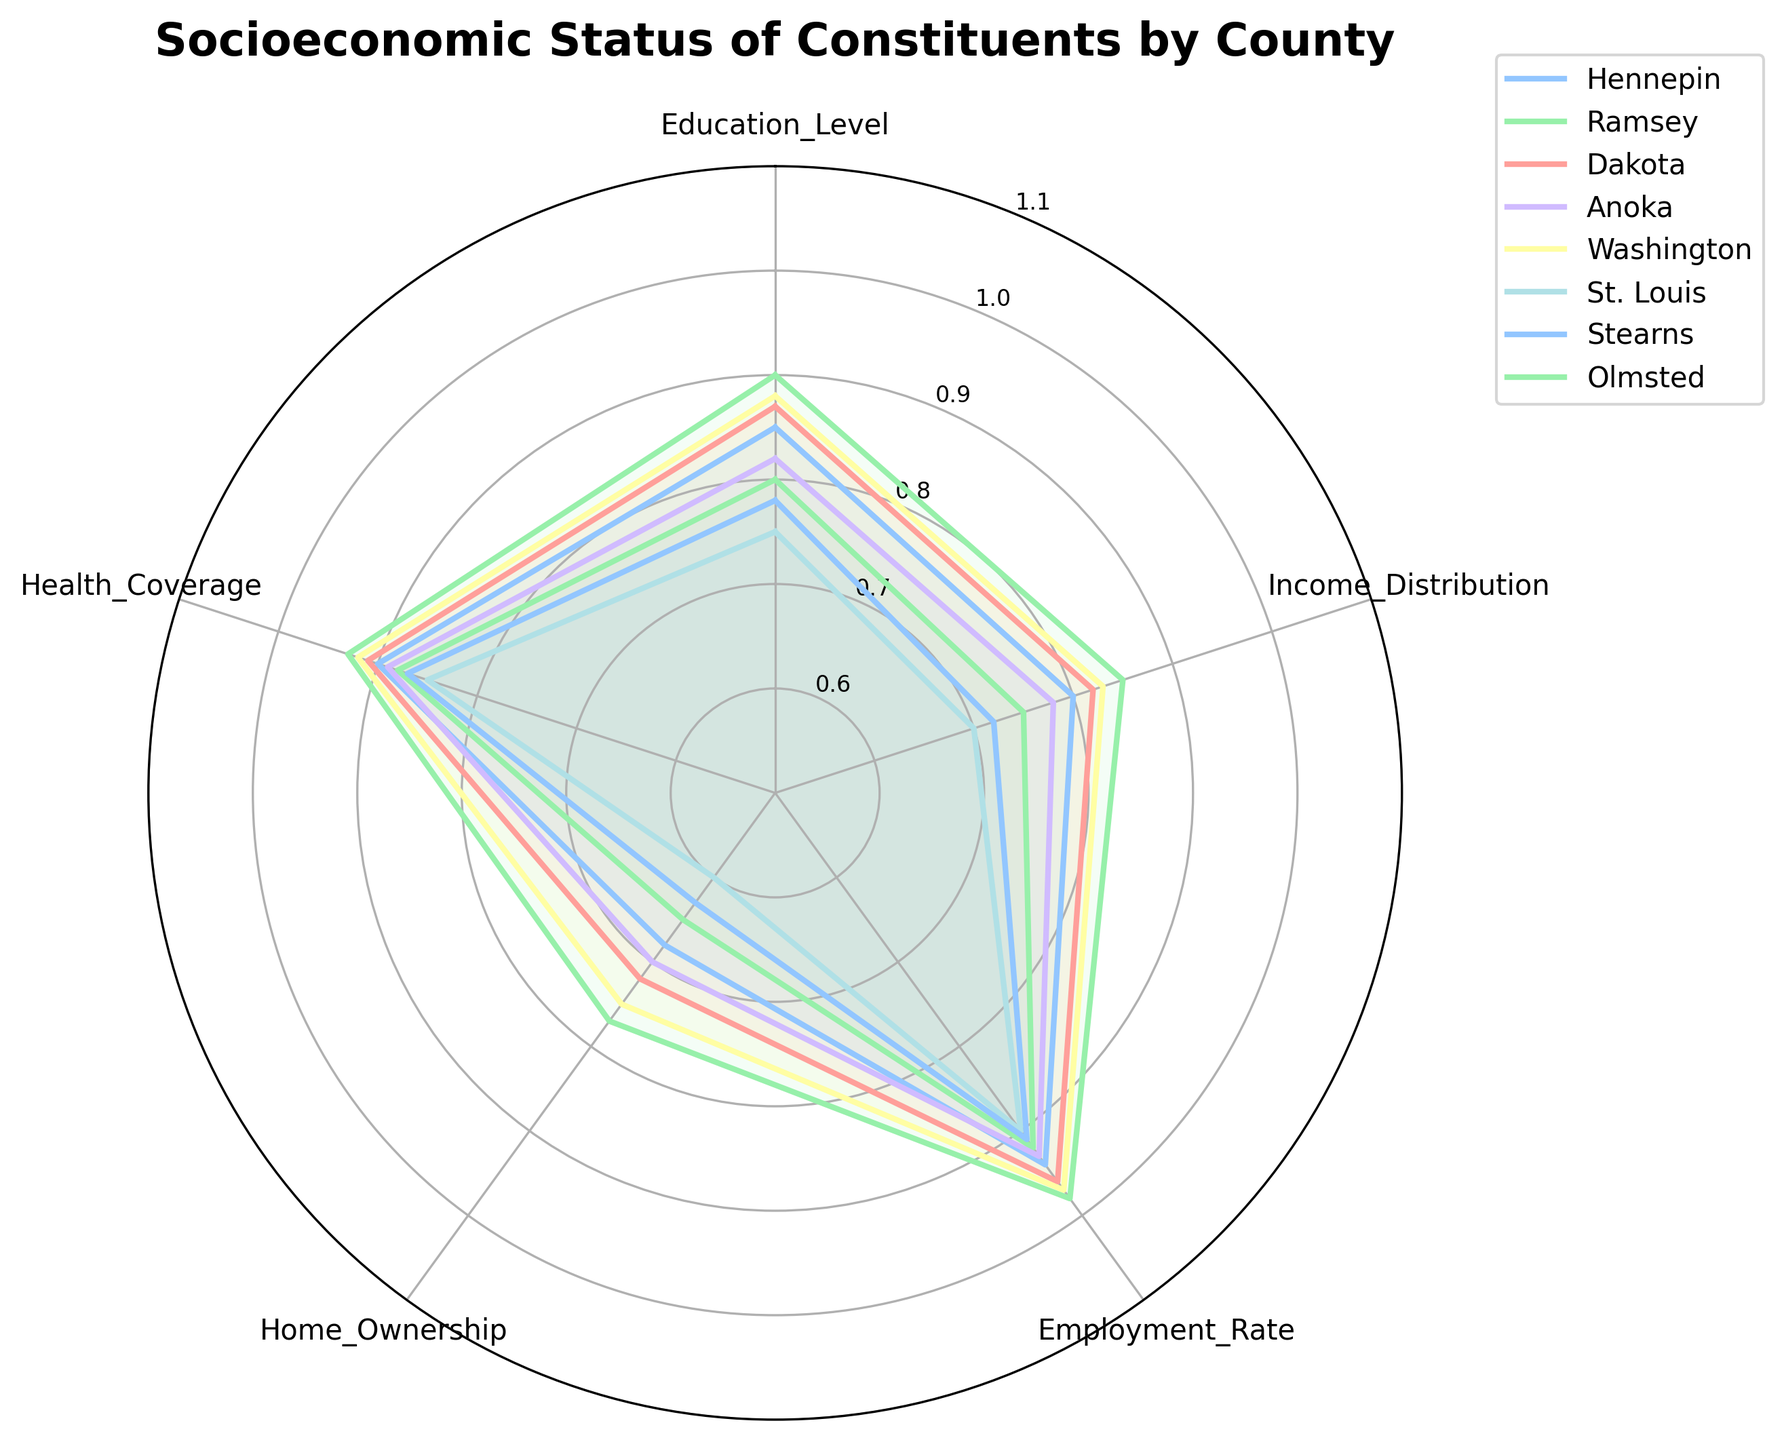What is the title of the figure? The title of the figure is displayed at the top of the radar chart. It provides an overview of what the chart depicts.
Answer: Socioeconomic Status of Constituents by County Which county has the highest education level? To find the county with the highest education level, look at the values along the 'Education Level' axis and identify the highest value across all counties.
Answer: Olmsted Which county has the lowest home ownership rate? Check the values plotted on the 'Home Ownership' axis and find the county with the lowest value in that category.
Answer: St. Louis What are the categories represented on the radar chart? The categories are indicated by the labels around the radar chart's perimeter. Each label represents a socio-economic metric.
Answer: Education Level, Income Distribution, Employment Rate, Home Ownership, Health Coverage How does Dakota's socioeconomic status compare to Washington's in terms of employment rate and health coverage? Compare the values on the 'Employment Rate' and 'Health Coverage' axes for both Dakota and Washington. Dakota has an employment rate of 0.96 and health coverage of 0.91. Washington has an employment rate of 0.97 and health coverage of 0.92.
Answer: Dakota: Employment Rate 0.96, Health Coverage 0.91; Washington: Employment Rate 0.97, Health Coverage 0.92 Which county has the most balanced socioeconomic status across all categories? A balanced socioeconomic status can be inferred from a radar chart that is roughly symmetrical or evenly distributed across all axes. By examining the chart, Olmsted and Washington appear to have values that are consistently high across all categories.
Answer: Olmsted or Washington Considering the employment rate across all counties, what is the average employment rate? Sum the employment rates of all counties and divide by the number of counties. (0.94 + 0.92 + 0.96 + 0.93 + 0.97 + 0.90 + 0.91 + 0.98) / 8 = 7.51 / 8 = 0.93875
Answer: 0.93875 Does Anoka have a higher income distribution than the average income distribution of all counties? Calculate the average income distribution across all counties and compare it to Anoka's value. Average: (0.80 + 0.75 + 0.82 + 0.78 + 0.83 + 0.70 + 0.72 + 0.85) / 8 = 6.25 / 8 = 0.78125. Anoka’s income distribution is 0.78, which is slightly below the average.
Answer: No Which county has the greatest discrepancy between home ownership and health coverage? Measure the difference between home ownership and health coverage for each county and identify the greatest difference. For St. Louis, the difference is 0.85 - 0.60 = 0.25, which is the largest among all counties.
Answer: St. Louis Identify the county with the lowest education level and the county with the lowest income distribution. Look at the values on the 'Education Level' and 'Income Distribution' axes. St. Louis has the lowest education level (0.75) and Ramsey has the lowest income distribution (0.70).
Answer: Education Level: St. Louis, Income Distribution: St. Louis 